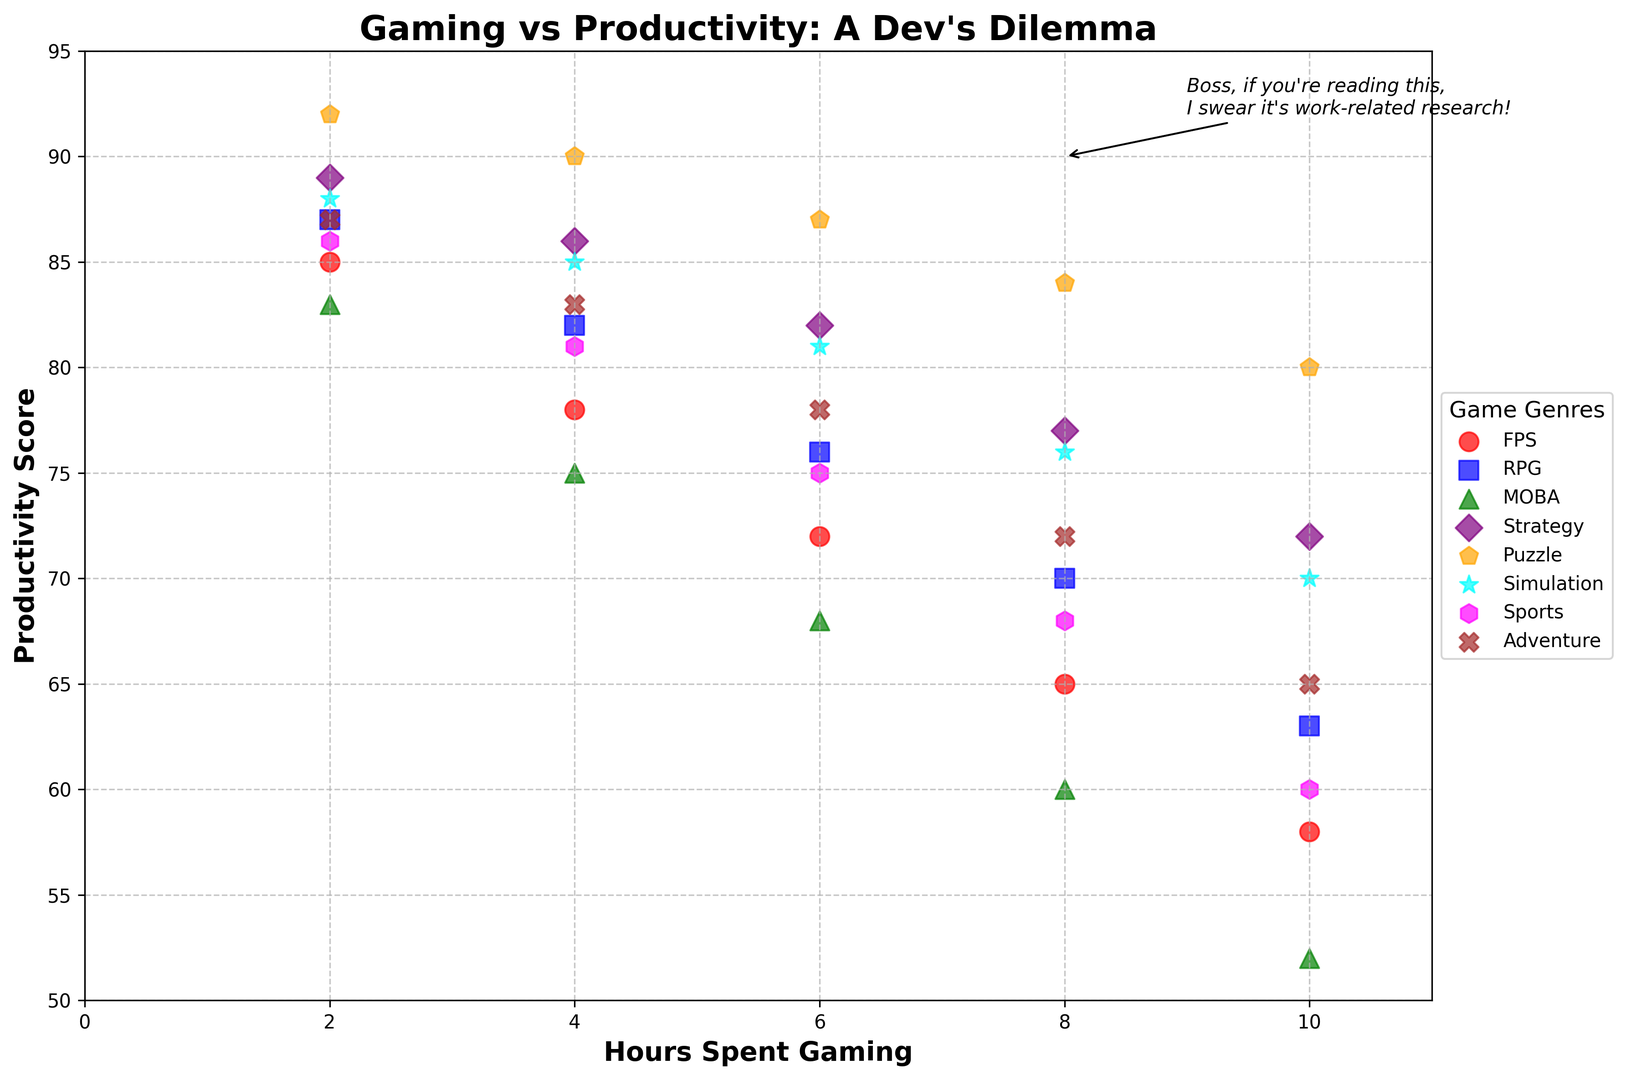Which game genre maintains the highest productivity score with 10 hours of gaming? Look for the productivity scores at 10 hours gaming across genres. The highest score is for Puzzle games.
Answer: Puzzle How does productivity compare between FPS and MOBA genres at 6 hours of gaming? Check the productivity scores of FPS and MOBA genres for 6 hours of gaming. FPS has a score of 72, while MOBA has 68.
Answer: FPS has higher productivity Which game genre is represented by the orange color and what is its productivity score range? Observe the colors used for each genre and note the orange color represents the Puzzle genre. The range can be obtained by observing the min and max values for Puzzle games.
Answer: Puzzle, 80-92 What happens to productivity scores for Strategy games as the hours spent gaming increase from 2 to 10 hours? Check the productivity scores for Strategy games at various gaming hours. There's a gradual decline from 89 at 2 hours to 72 at 10 hours.
Answer: Gradual decline Which genre shows the steepest decline in productivity scores from 2 to 10 hours of gaming? Compare the changes in productivity scores for all genres from 2 to 10 hours. MOBA shows a steep decline from 83 to 52.
Answer: MOBA What is the approximate average productivity score for Simulation games across all hours? Find the productivity scores for Simulation games at all given hours and compute their average: (88 + 85 + 81 + 76 + 70)/5 = 80.
Answer: 80 At 8 hours of gaming, which genre has the lowest productivity score? Look for the productivity scores for all genres at 8 hours of gaming. MOBA has the lowest score of 60.
Answer: MOBA How does productivity change for Adventure games between 4 and 10 hours of gaming? Check the productivity scores for Adventure games at 4 hours and 10 hours. It decreases from 83 at 4 hours to 65 at 10 hours.
Answer: Decreases What genre is marked by the brown 'X' marker and what is its highest productivity score? Identify the genres by the markers; the brown 'X' represents the Adventure genre. Its highest productivity score is 87.
Answer: Adventure, 87 